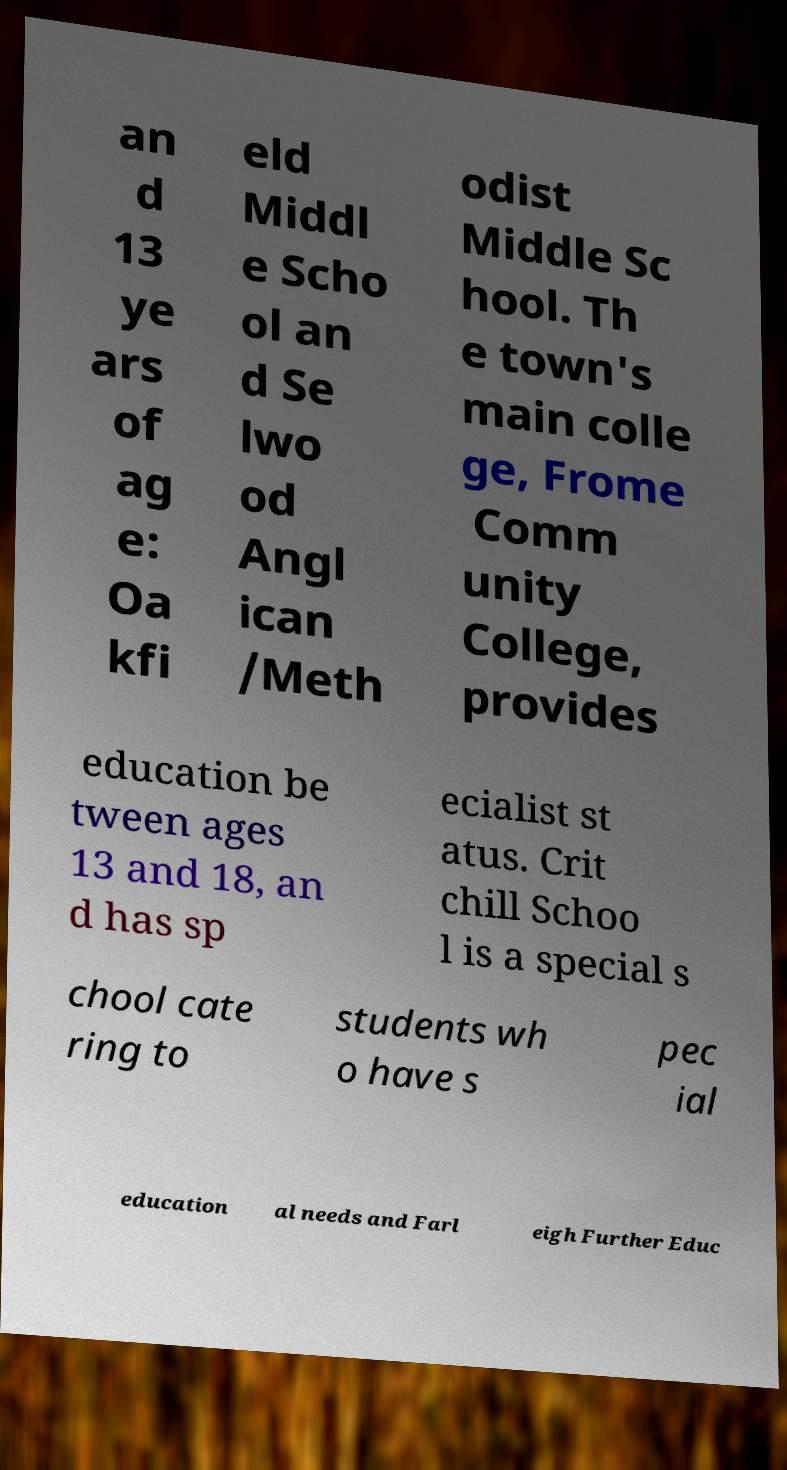There's text embedded in this image that I need extracted. Can you transcribe it verbatim? an d 13 ye ars of ag e: Oa kfi eld Middl e Scho ol an d Se lwo od Angl ican /Meth odist Middle Sc hool. Th e town's main colle ge, Frome Comm unity College, provides education be tween ages 13 and 18, an d has sp ecialist st atus. Crit chill Schoo l is a special s chool cate ring to students wh o have s pec ial education al needs and Farl eigh Further Educ 